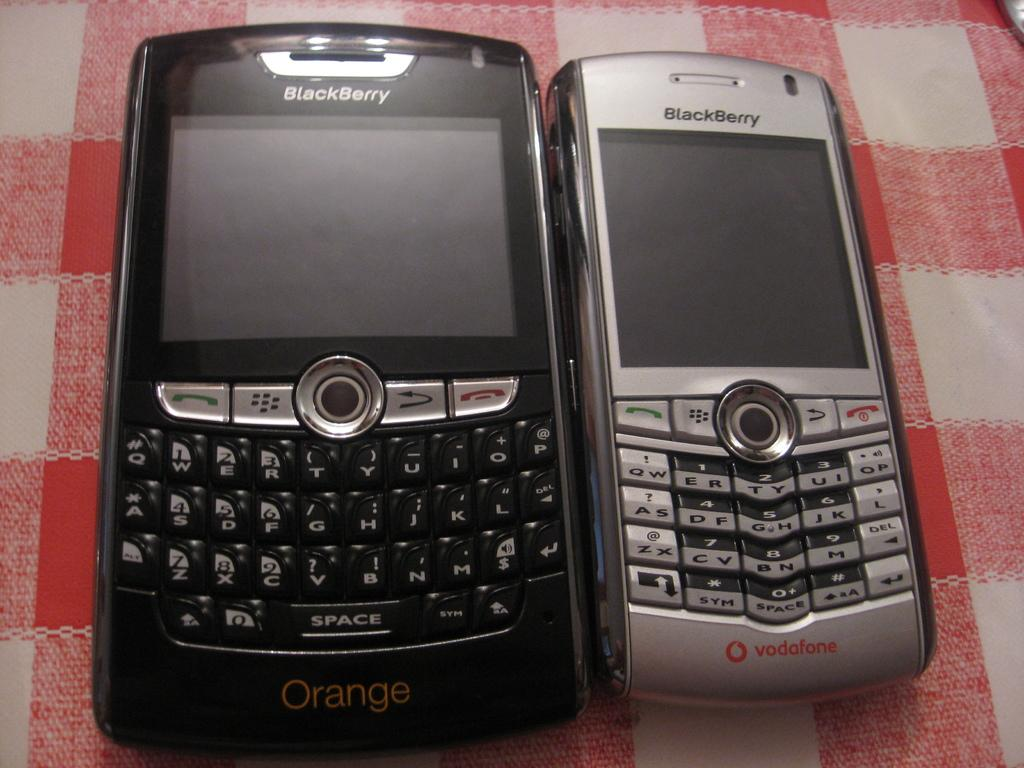<image>
Give a short and clear explanation of the subsequent image. Two old style phones, both of which have Blackberry on them. 